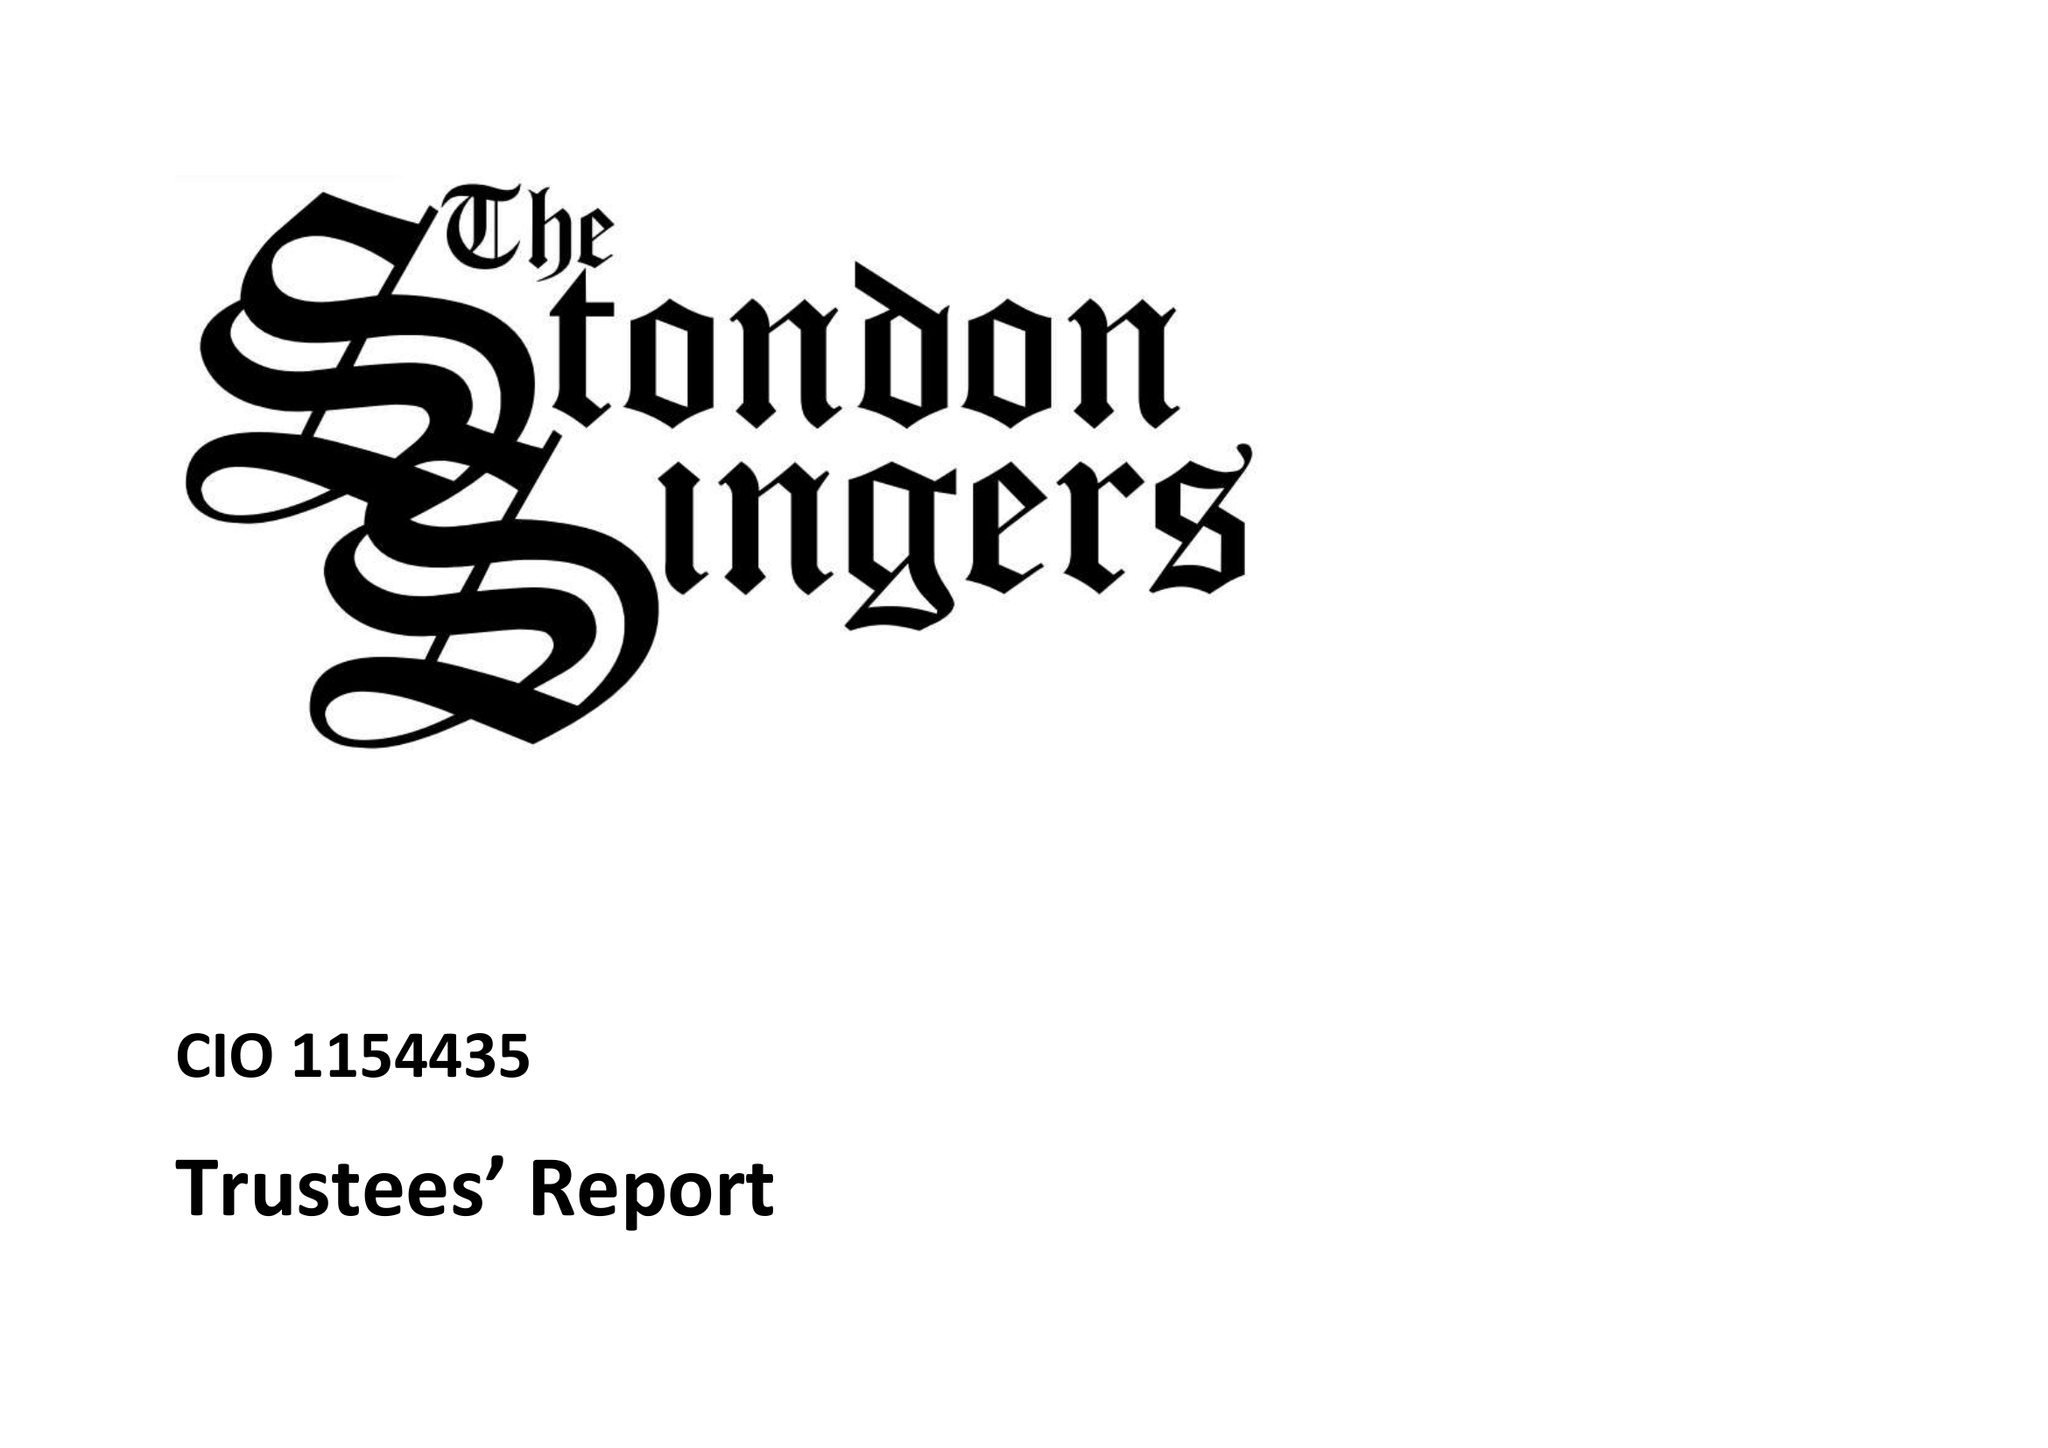What is the value for the address__post_town?
Answer the question using a single word or phrase. BRENTWOOD 